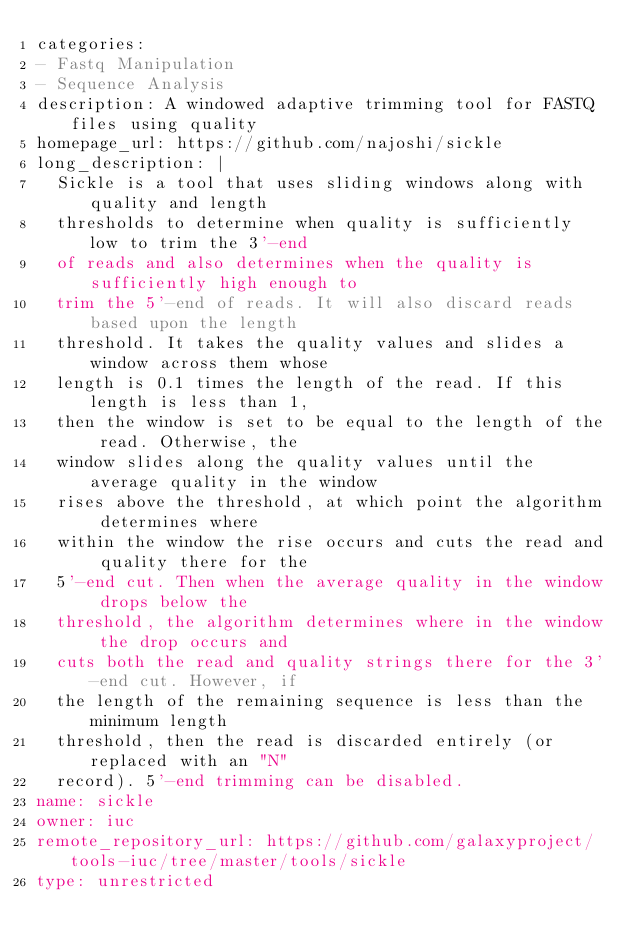<code> <loc_0><loc_0><loc_500><loc_500><_YAML_>categories:
- Fastq Manipulation
- Sequence Analysis
description: A windowed adaptive trimming tool for FASTQ files using quality
homepage_url: https://github.com/najoshi/sickle
long_description: |
  Sickle is a tool that uses sliding windows along with quality and length
  thresholds to determine when quality is sufficiently low to trim the 3'-end
  of reads and also determines when the quality is sufficiently high enough to
  trim the 5'-end of reads. It will also discard reads based upon the length
  threshold. It takes the quality values and slides a window across them whose
  length is 0.1 times the length of the read. If this length is less than 1,
  then the window is set to be equal to the length of the read. Otherwise, the
  window slides along the quality values until the average quality in the window
  rises above the threshold, at which point the algorithm determines where
  within the window the rise occurs and cuts the read and quality there for the
  5'-end cut. Then when the average quality in the window drops below the
  threshold, the algorithm determines where in the window the drop occurs and
  cuts both the read and quality strings there for the 3'-end cut. However, if
  the length of the remaining sequence is less than the minimum length
  threshold, then the read is discarded entirely (or replaced with an "N"
  record). 5'-end trimming can be disabled.
name: sickle
owner: iuc
remote_repository_url: https://github.com/galaxyproject/tools-iuc/tree/master/tools/sickle
type: unrestricted
</code> 